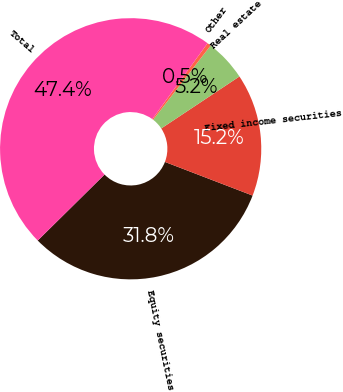<chart> <loc_0><loc_0><loc_500><loc_500><pie_chart><fcel>Equity securities<fcel>Fixed income securities<fcel>Real estate<fcel>Other<fcel>Total<nl><fcel>31.77%<fcel>15.17%<fcel>5.17%<fcel>0.47%<fcel>47.42%<nl></chart> 